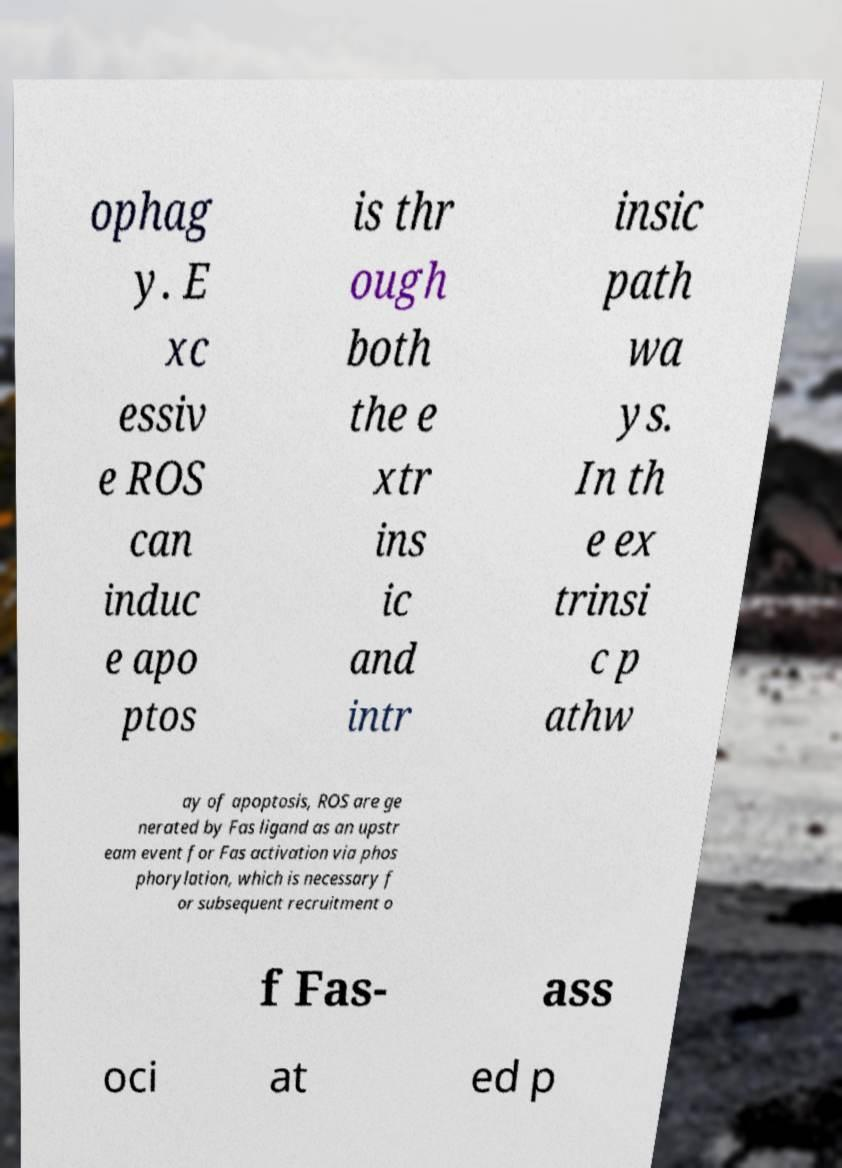Could you assist in decoding the text presented in this image and type it out clearly? ophag y. E xc essiv e ROS can induc e apo ptos is thr ough both the e xtr ins ic and intr insic path wa ys. In th e ex trinsi c p athw ay of apoptosis, ROS are ge nerated by Fas ligand as an upstr eam event for Fas activation via phos phorylation, which is necessary f or subsequent recruitment o f Fas- ass oci at ed p 